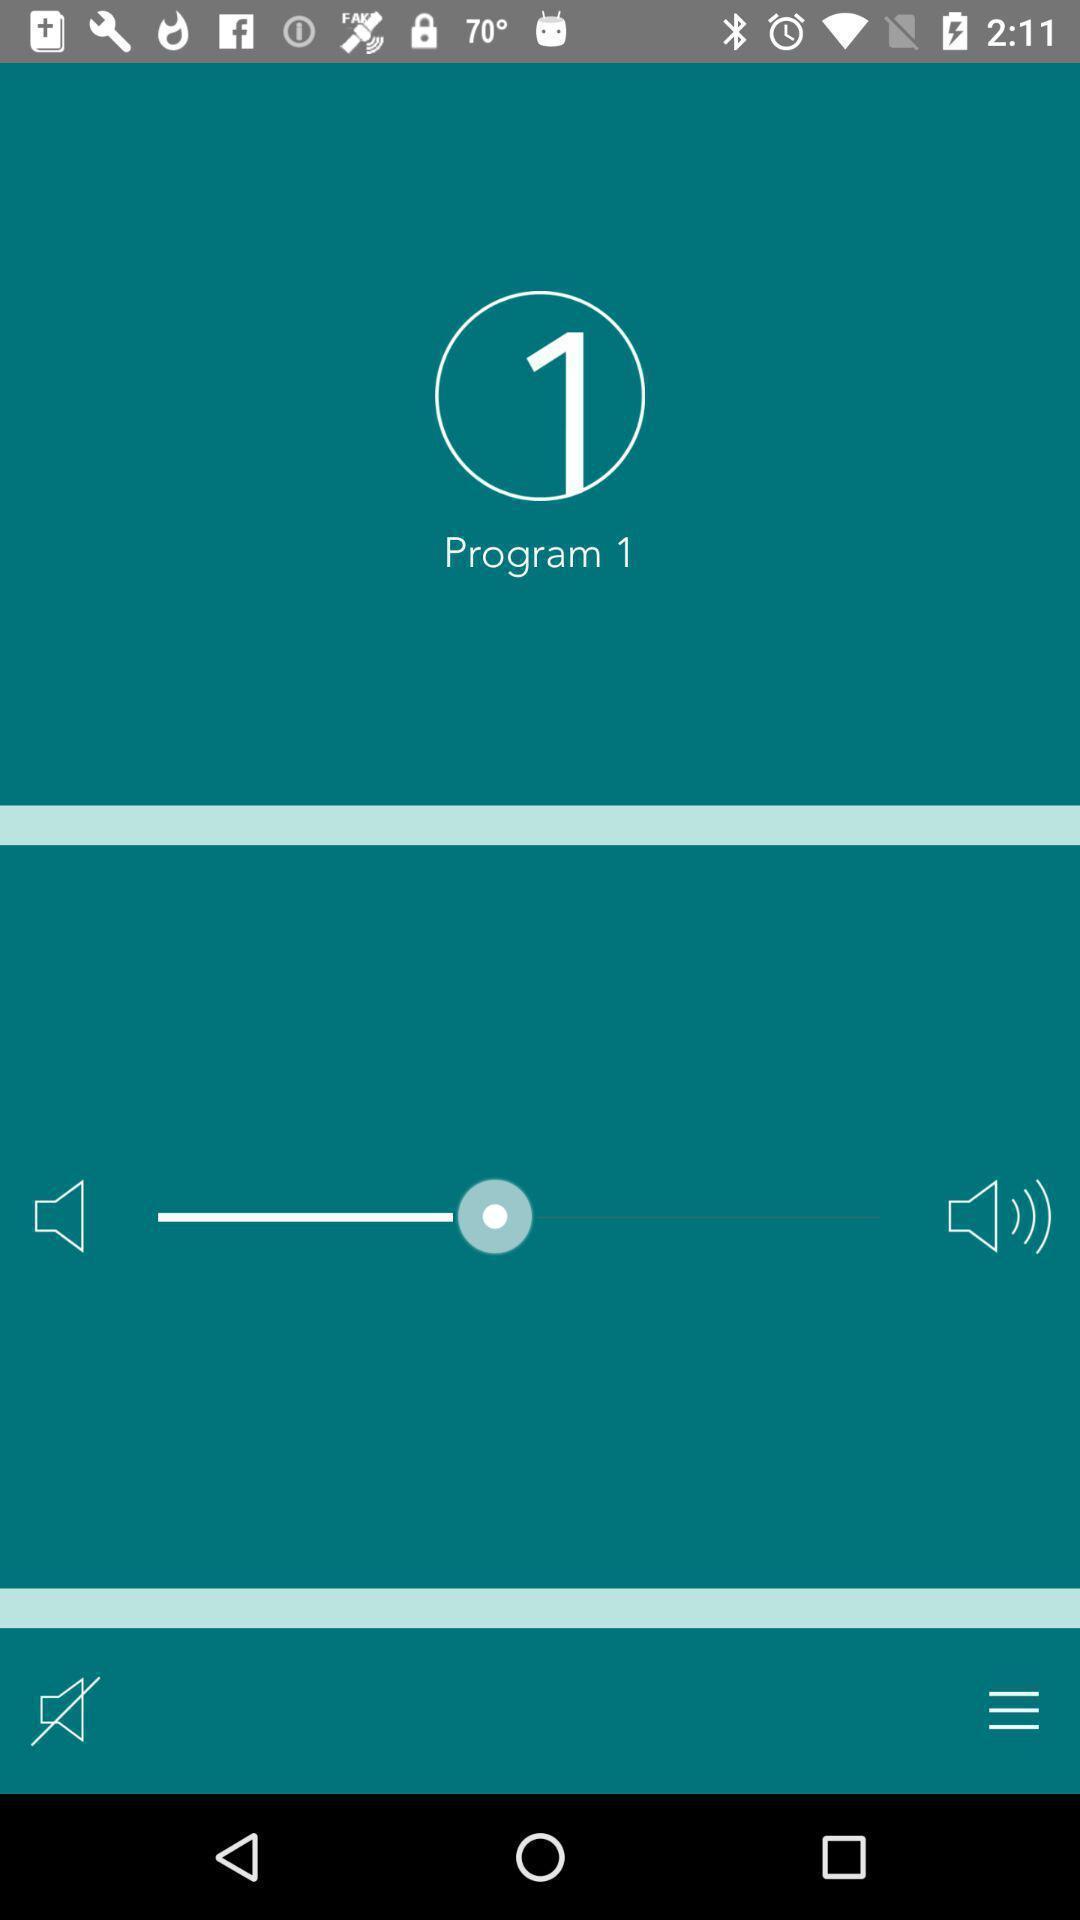Describe the content in this image. Screen showing program 1 with volume level option. 